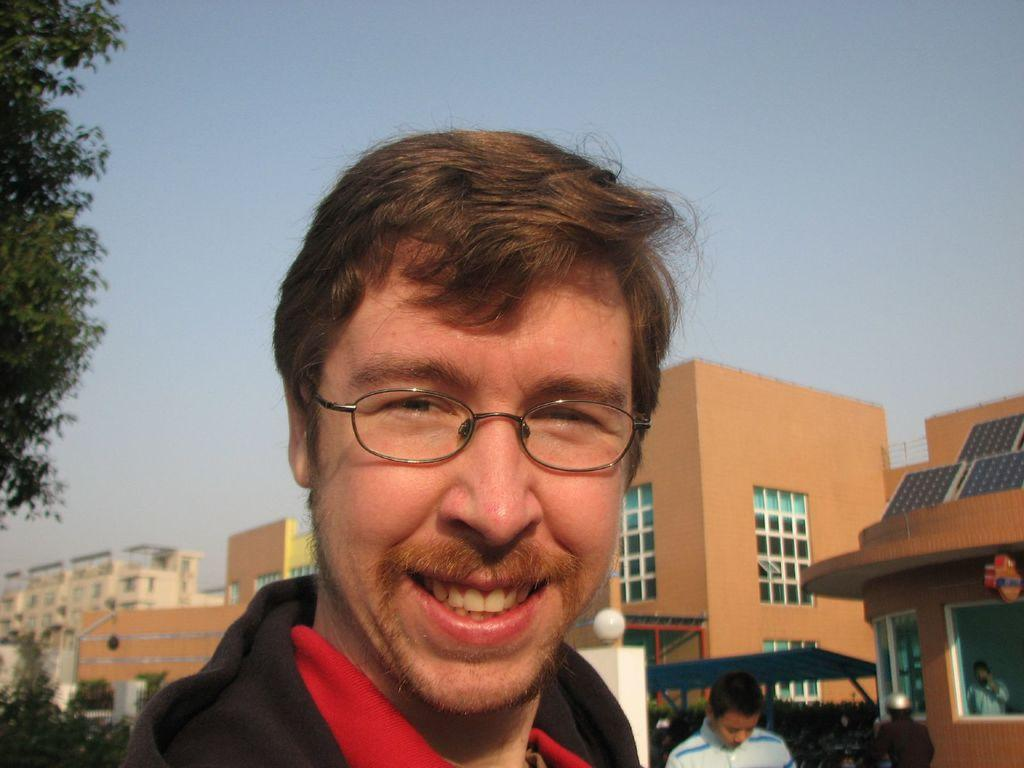What is the expression of the person in the image? The person in the image is smiling. What accessory is the person wearing? The person is wearing spectacles. Can you describe the person behind the first person? There is another person behind the first person, but no specific details are provided about them. What can be seen in the background of the image? There are buildings, trees, and the sky visible in the background of the image. What type of wine is the person holding in the image? There is no wine present in the image; the person is not holding any wine. How many daughters can be seen in the image? There is no mention of a daughter or any children in the image. 